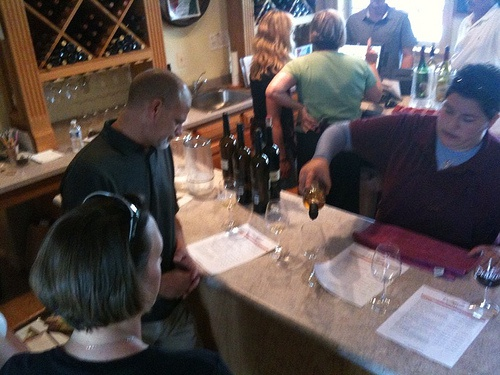Describe the objects in this image and their specific colors. I can see dining table in maroon, darkgray, black, tan, and gray tones, people in maroon, black, purple, navy, and darkblue tones, people in maroon, black, gray, darkgray, and purple tones, people in maroon, black, and gray tones, and people in maroon, black, and brown tones in this image. 